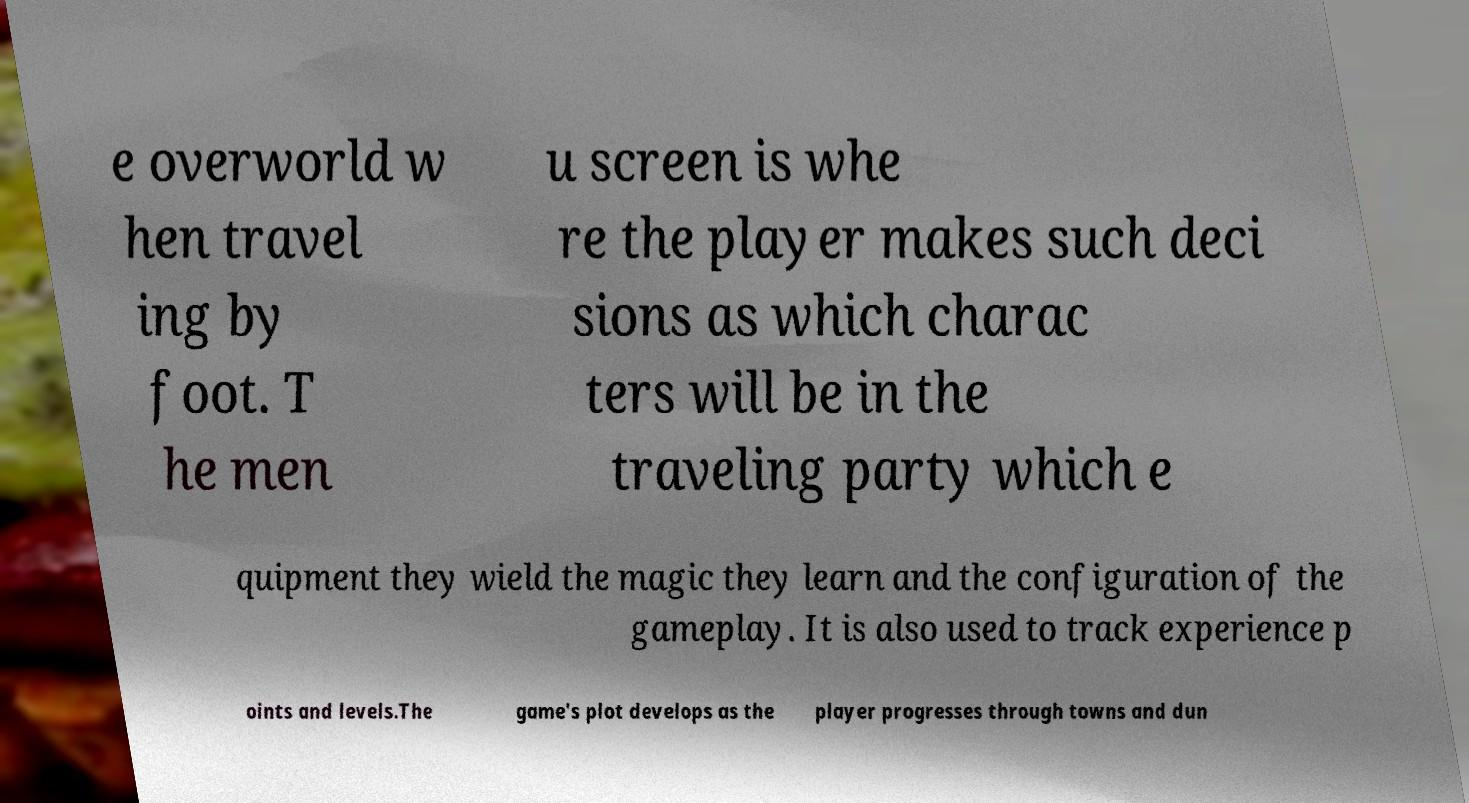Could you extract and type out the text from this image? e overworld w hen travel ing by foot. T he men u screen is whe re the player makes such deci sions as which charac ters will be in the traveling party which e quipment they wield the magic they learn and the configuration of the gameplay. It is also used to track experience p oints and levels.The game's plot develops as the player progresses through towns and dun 